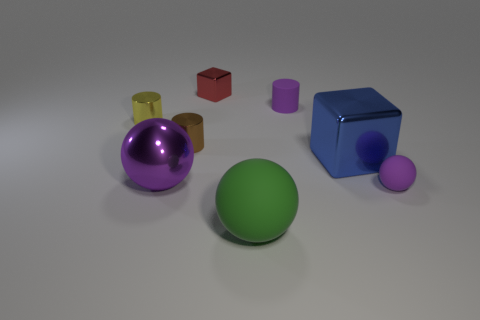Add 1 big gray metal things. How many objects exist? 9 Subtract all spheres. How many objects are left? 5 Add 7 small metal blocks. How many small metal blocks are left? 8 Add 6 red metallic objects. How many red metallic objects exist? 7 Subtract 1 purple cylinders. How many objects are left? 7 Subtract all tiny blue things. Subtract all small brown objects. How many objects are left? 7 